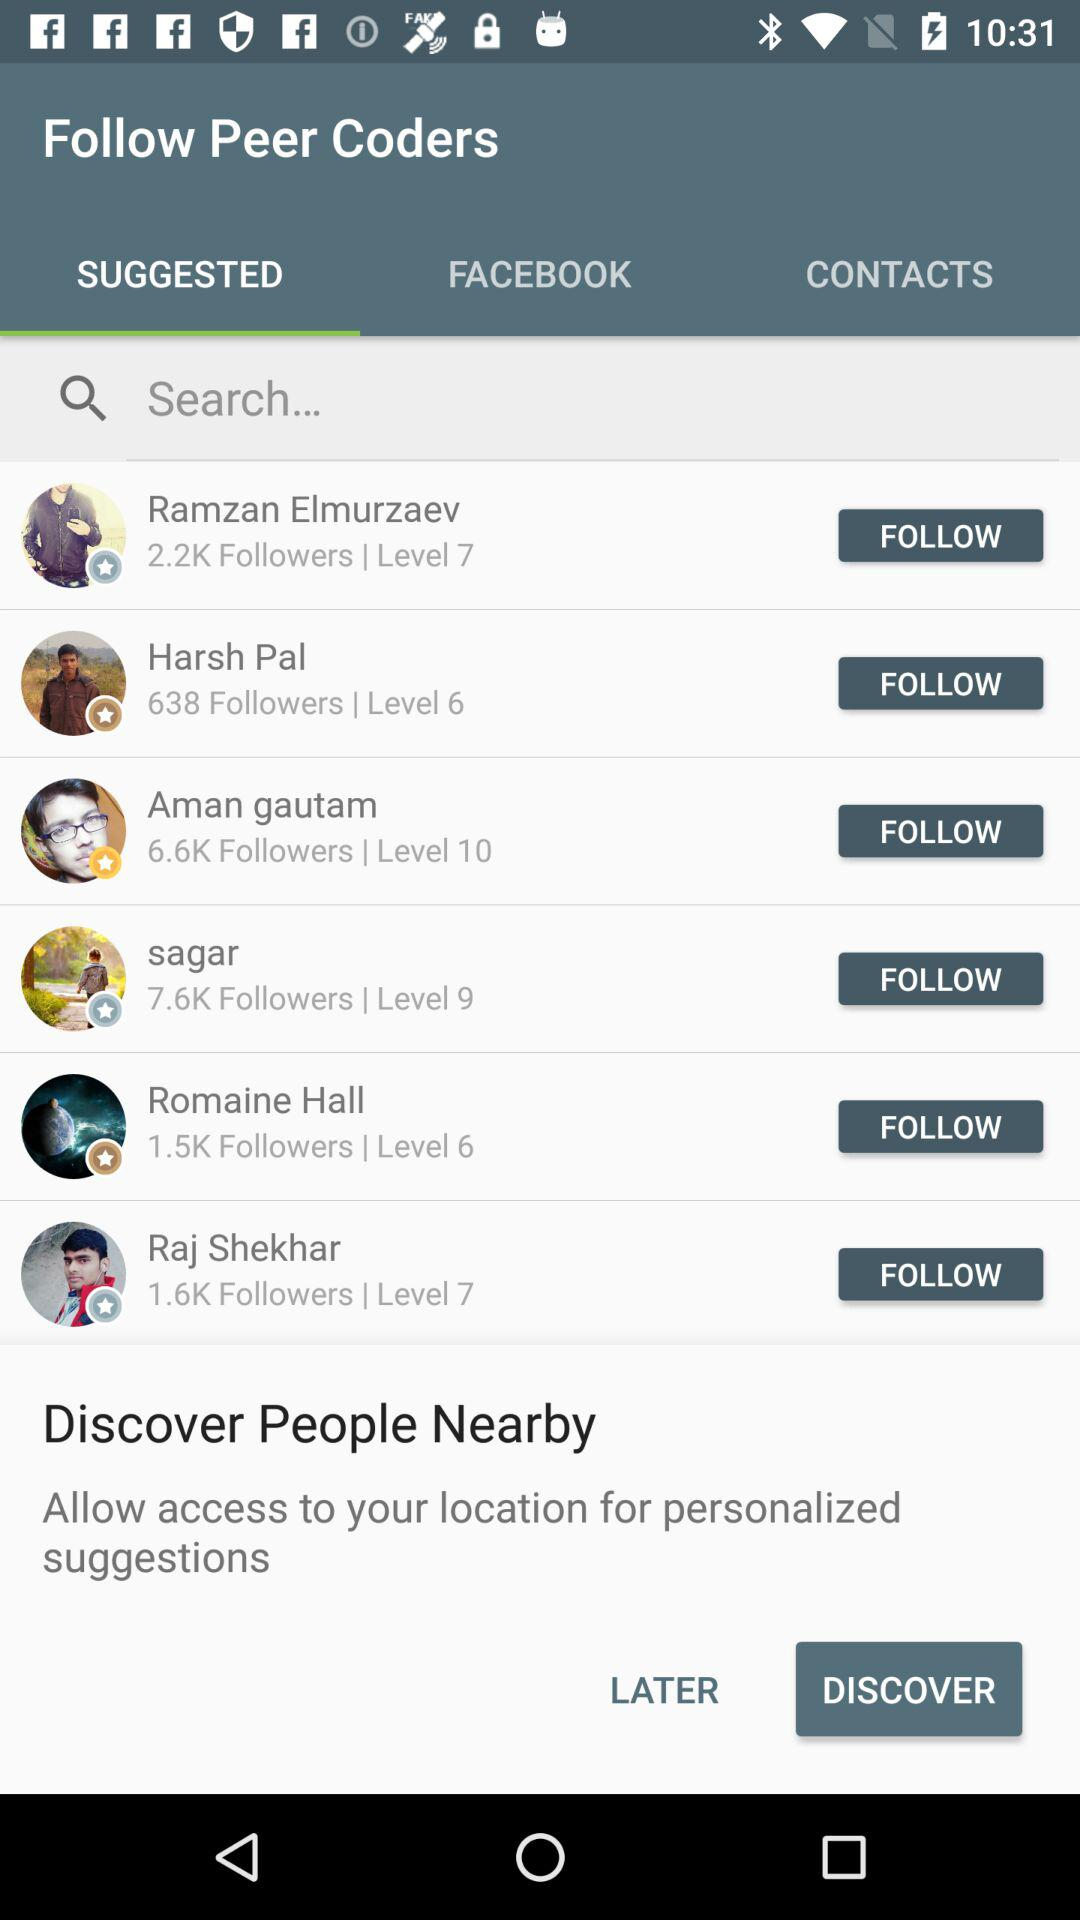What is the number of followers that Harsh Pal has? The number of followers is 638. 